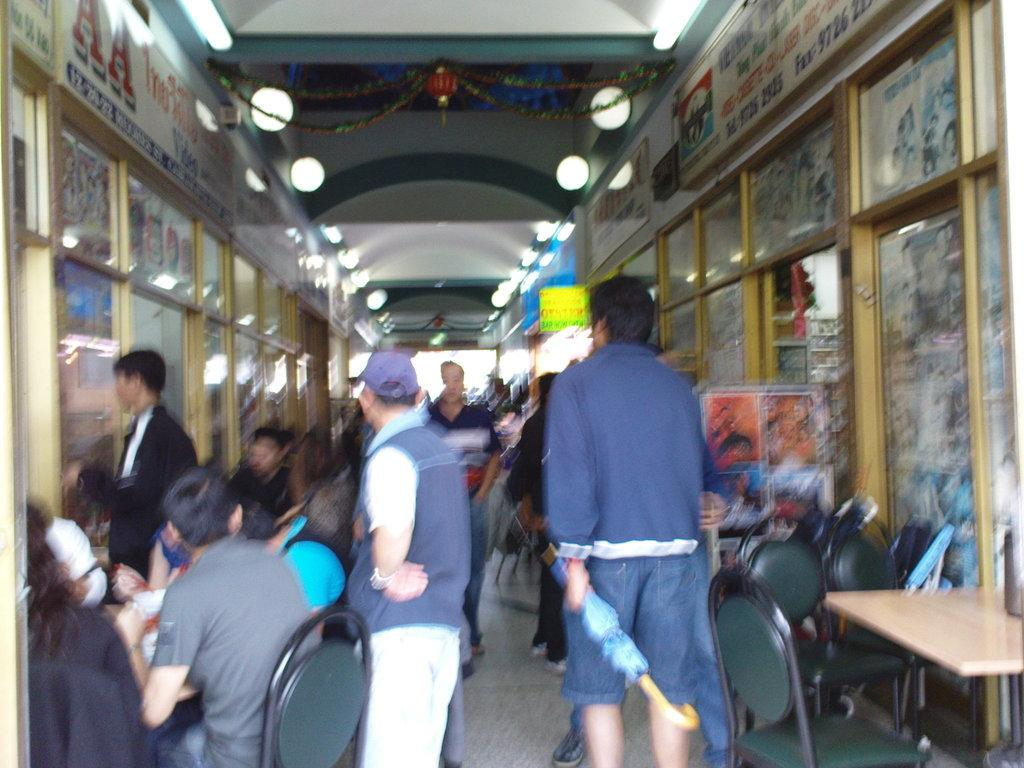What type of building is visible in the image? There is a building with a glass wall in the image. Are there any decorations or markings on the building? Yes, there are stickers on the building. What are the people in the image doing? There is a man sitting on chairs around a table, and there are men walking in the image. What sound does the father make when he enters the image? There is no father present in the image, so it is not possible to determine what sound they might make upon entering. 